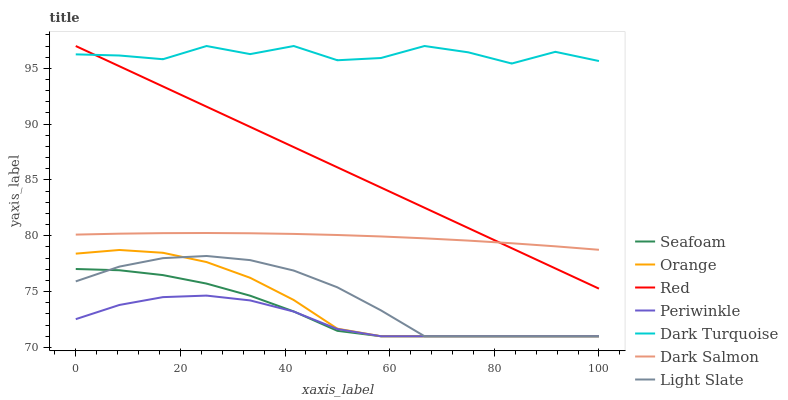Does Periwinkle have the minimum area under the curve?
Answer yes or no. Yes. Does Dark Turquoise have the maximum area under the curve?
Answer yes or no. Yes. Does Seafoam have the minimum area under the curve?
Answer yes or no. No. Does Seafoam have the maximum area under the curve?
Answer yes or no. No. Is Red the smoothest?
Answer yes or no. Yes. Is Dark Turquoise the roughest?
Answer yes or no. Yes. Is Seafoam the smoothest?
Answer yes or no. No. Is Seafoam the roughest?
Answer yes or no. No. Does Light Slate have the lowest value?
Answer yes or no. Yes. Does Dark Turquoise have the lowest value?
Answer yes or no. No. Does Red have the highest value?
Answer yes or no. Yes. Does Seafoam have the highest value?
Answer yes or no. No. Is Orange less than Red?
Answer yes or no. Yes. Is Red greater than Periwinkle?
Answer yes or no. Yes. Does Light Slate intersect Orange?
Answer yes or no. Yes. Is Light Slate less than Orange?
Answer yes or no. No. Is Light Slate greater than Orange?
Answer yes or no. No. Does Orange intersect Red?
Answer yes or no. No. 